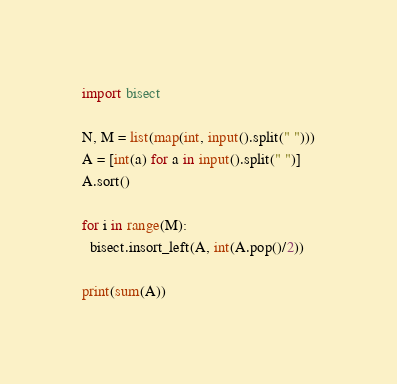<code> <loc_0><loc_0><loc_500><loc_500><_Python_>import bisect 

N, M = list(map(int, input().split(" ")))
A = [int(a) for a in input().split(" ")]
A.sort()

for i in range(M):
  bisect.insort_left(A, int(A.pop()/2))
  
print(sum(A))</code> 